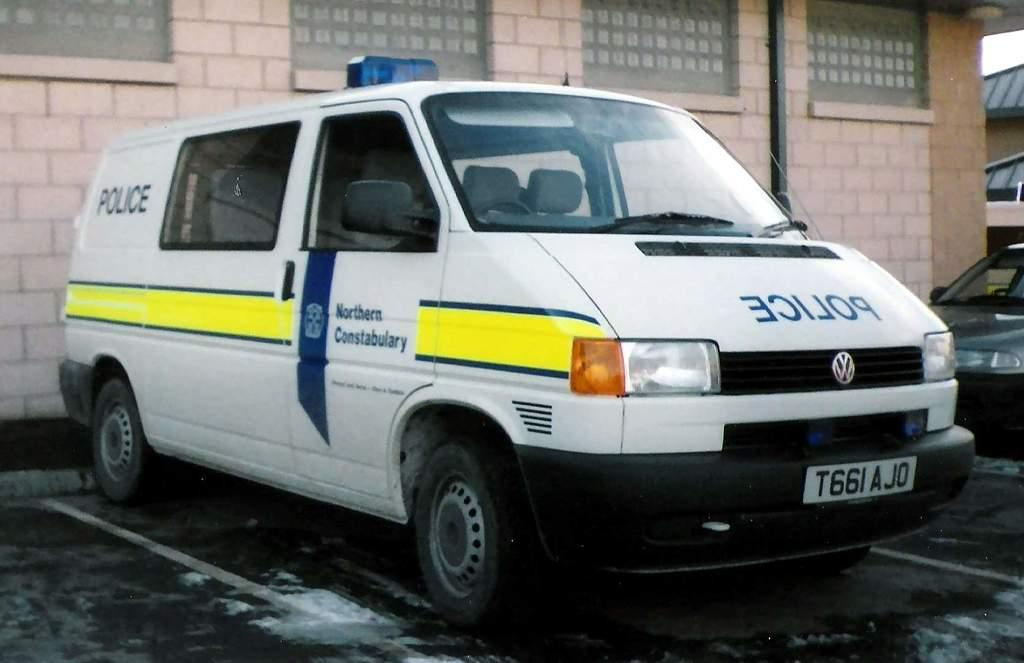What is the main subject in the center of the image? There is a van in the center of the image. What can be seen in the background of the image? There is a building in the background of the image. Are there any other vehicles visible in the image? Yes, there is another vehicle on the right side of the image. What type of pies are being sold at the van in the image? There is no indication in the image that the van is selling pies or any other food items. 